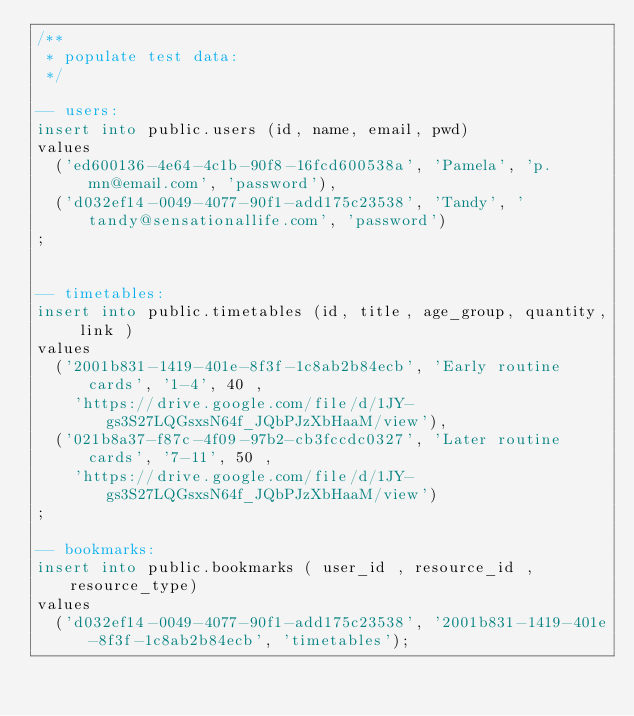Convert code to text. <code><loc_0><loc_0><loc_500><loc_500><_SQL_>/**
 * populate test data:
 */

-- users:
insert into public.users (id, name, email, pwd)
values 
	('ed600136-4e64-4c1b-90f8-16fcd600538a', 'Pamela', 'p.mn@email.com', 'password'),
	('d032ef14-0049-4077-90f1-add175c23538', 'Tandy', 'tandy@sensationallife.com', 'password')
;


-- timetables:
insert into public.timetables (id, title, age_group, quantity, link )
values
	('2001b831-1419-401e-8f3f-1c8ab2b84ecb', 'Early routine cards', '1-4', 40 , 
		'https://drive.google.com/file/d/1JY-gs3S27LQGsxsN64f_JQbPJzXbHaaM/view'),
	('021b8a37-f87c-4f09-97b2-cb3fccdc0327', 'Later routine cards', '7-11', 50 , 
		'https://drive.google.com/file/d/1JY-gs3S27LQGsxsN64f_JQbPJzXbHaaM/view')
;

-- bookmarks:
insert into public.bookmarks ( user_id , resource_id , resource_type)
values
	('d032ef14-0049-4077-90f1-add175c23538', '2001b831-1419-401e-8f3f-1c8ab2b84ecb', 'timetables');
</code> 